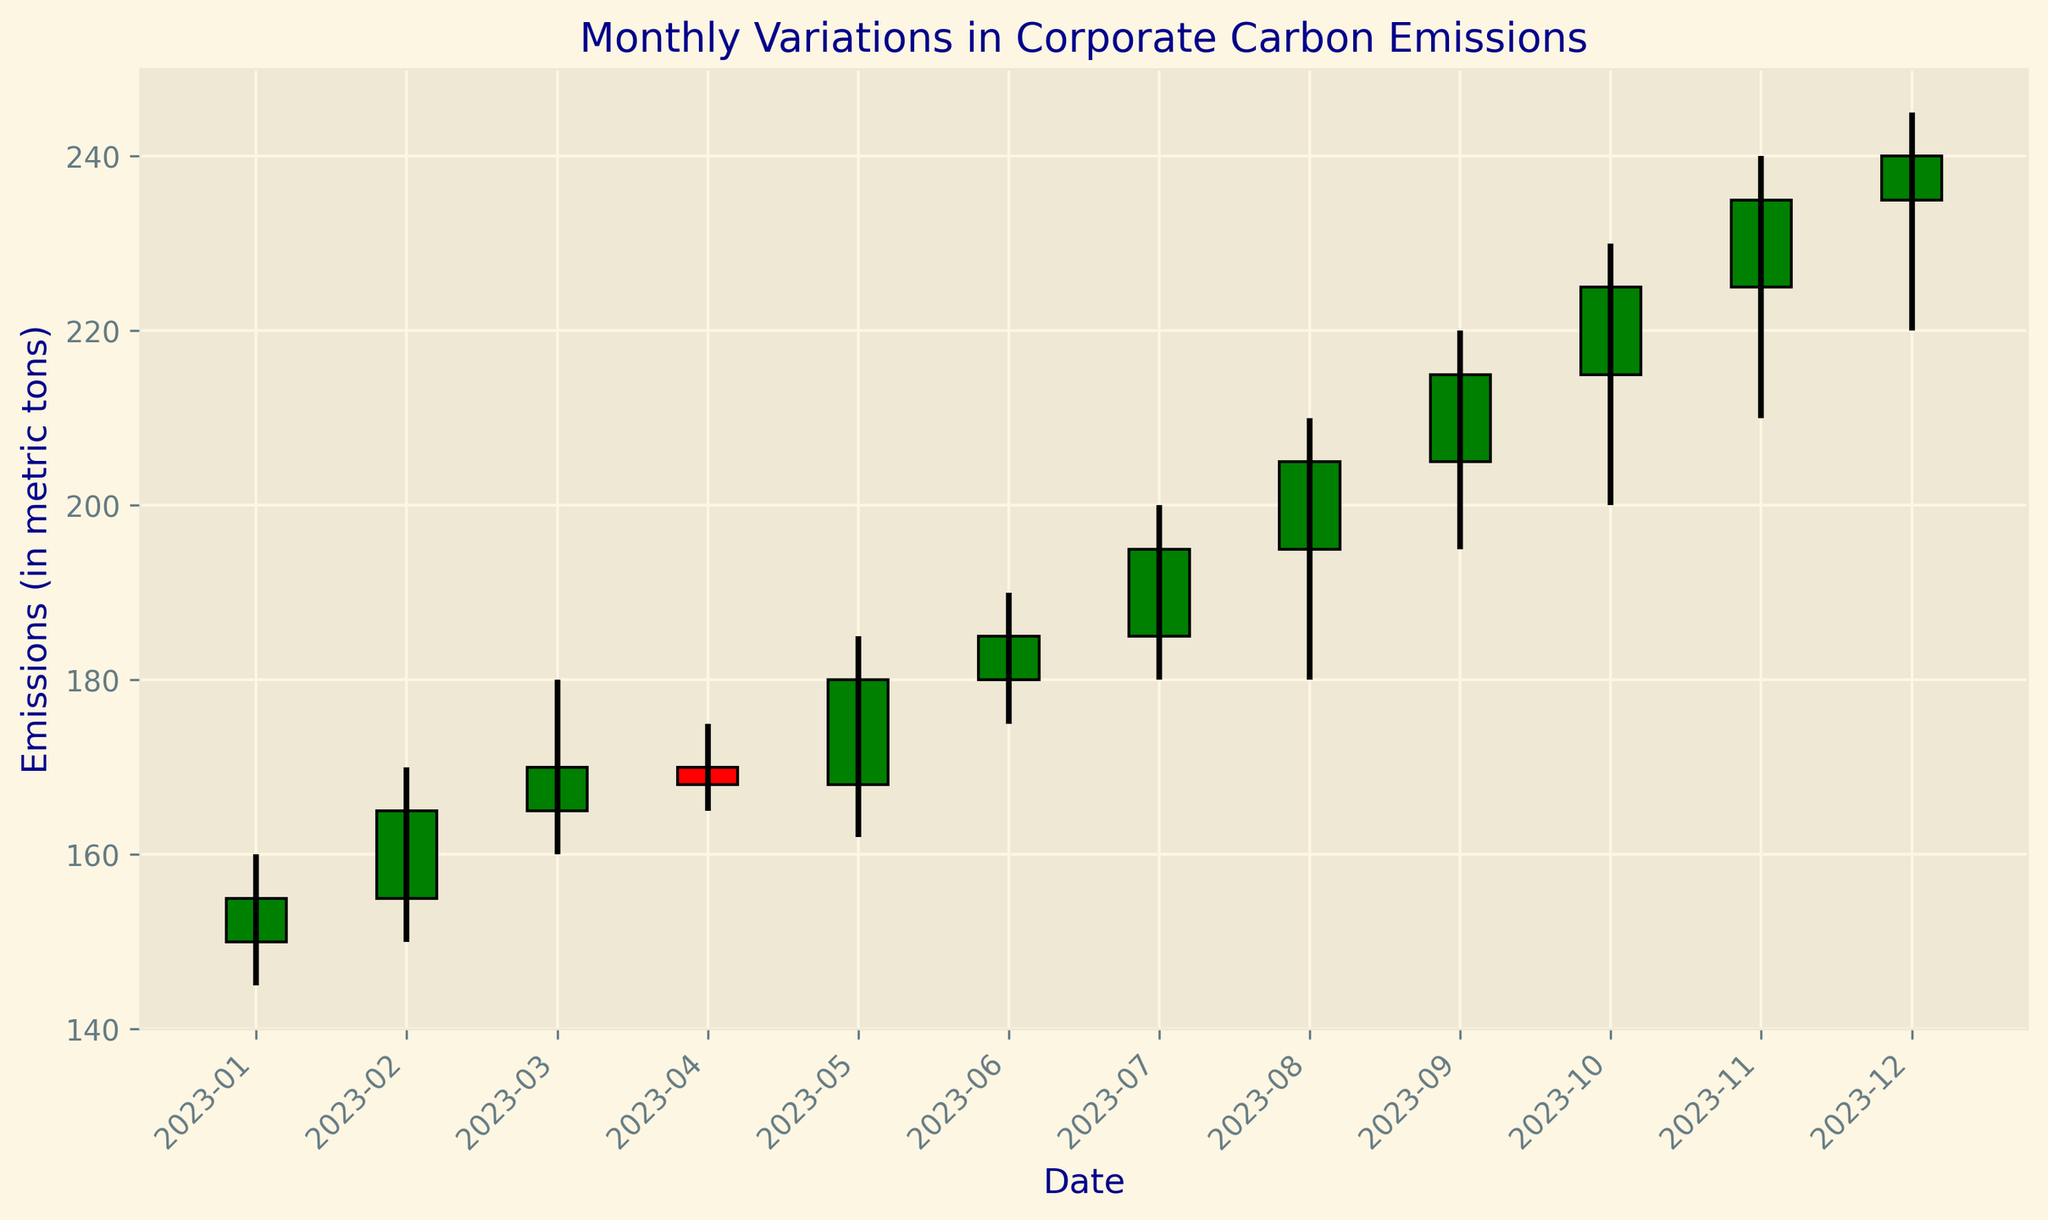What month shows the highest closing carbon emission? By examining the candlestick chart, the month with the highest closing value can be identified as December 2023, where the closing value reaches 240 metric tons.
Answer: December 2023 Which month shows a lower closing value than its opening value? To answer this, we need to identify the months where the closing value is less than the opening value. On the chart, April 2023 can be seen having a closing value of 168 which is lower than its opening value of 170.
Answer: April 2023 What is the range of carbon emissions for August 2023? The range can be computed as the difference between the high and low values of the month. For August 2023, the high value is 210, and the low value is 180. Therefore, the range is 210 - 180 = 30.
Answer: 30 In which month did the carbon emissions see the greatest increase from the opening value to the closing value? By comparing the differences between the opening and closing values for each month, August 2023 shows the greatest increase (205 - 195 = 10).
Answer: August 2023 What is the average closing value of carbon emissions for the first quarter (Jan-Mar) of 2023? First, sum up the closing values for January, February, and March, which are 155, 165, and 170 respectively. The total is 155 + 165 + 170 = 490. Divide this by 3 to get the average: 490 / 3 ≈ 163.33.
Answer: 163.33 Which month reports the lowest high value of carbon emissions? By checking the high values for each month on the chart, January 2023 shows the lowest high value, which is 160.
Answer: January 2023 How many months show a closing value greater than or equal to 200 metric tons? The candlestick chart shows that September, October, November, and December 2023 all have closing values greater than or equal to 200. So, there are 4 months that meet this criterion.
Answer: 4 Compare the opening carbon emissions in June 2023 and October 2023. Which one is higher? From the chart, June 2023 has an opening value of 180, and October 2023 has an opening value of 215. Therefore, October 2023 has a higher opening value.
Answer: October 2023 